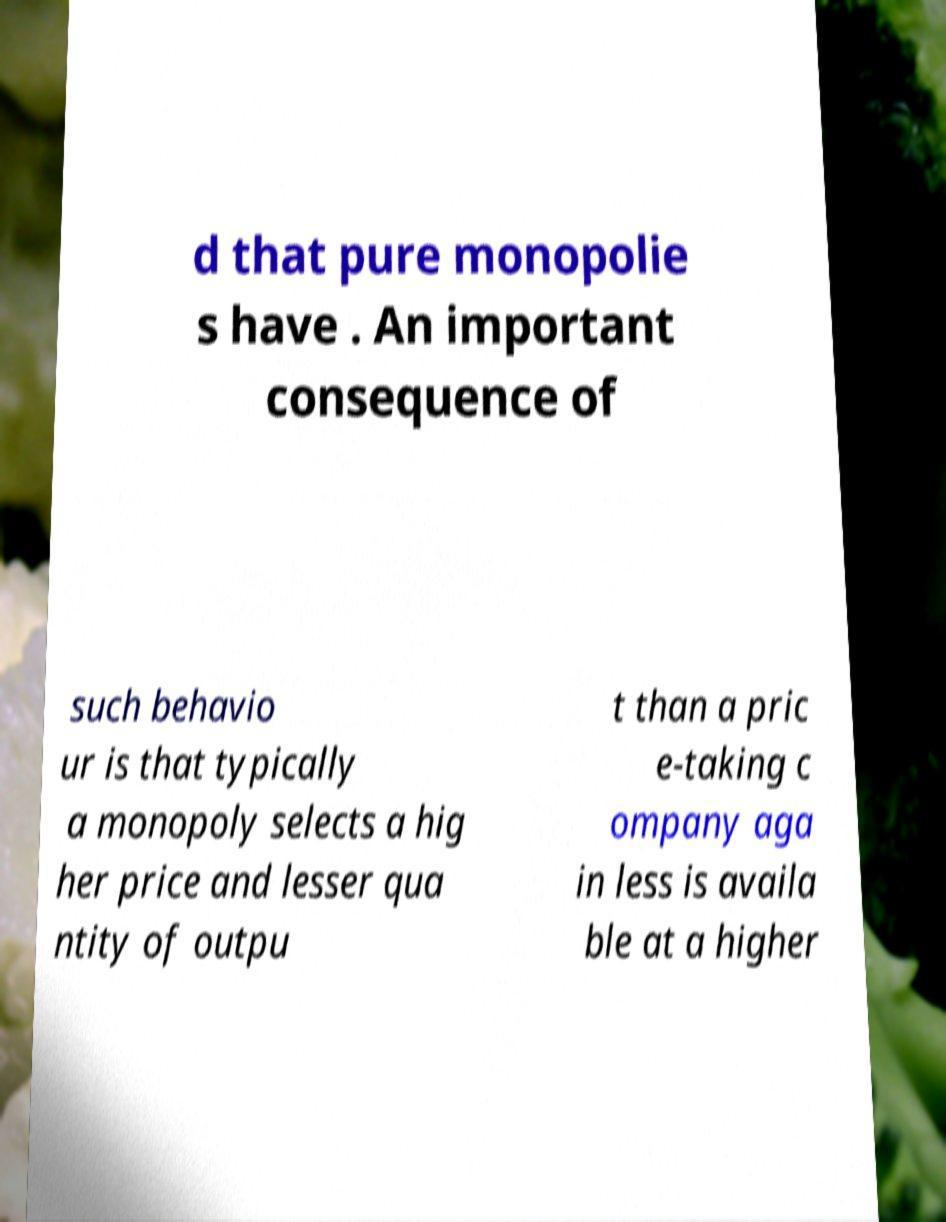Please read and relay the text visible in this image. What does it say? d that pure monopolie s have . An important consequence of such behavio ur is that typically a monopoly selects a hig her price and lesser qua ntity of outpu t than a pric e-taking c ompany aga in less is availa ble at a higher 